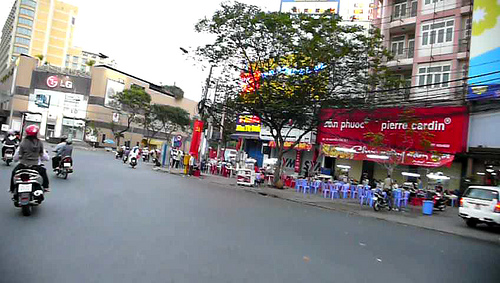Do the store and the tree have a different colors? Yes, the store and the tree differ in colors; the store has vibrant reds while the tree is green. 